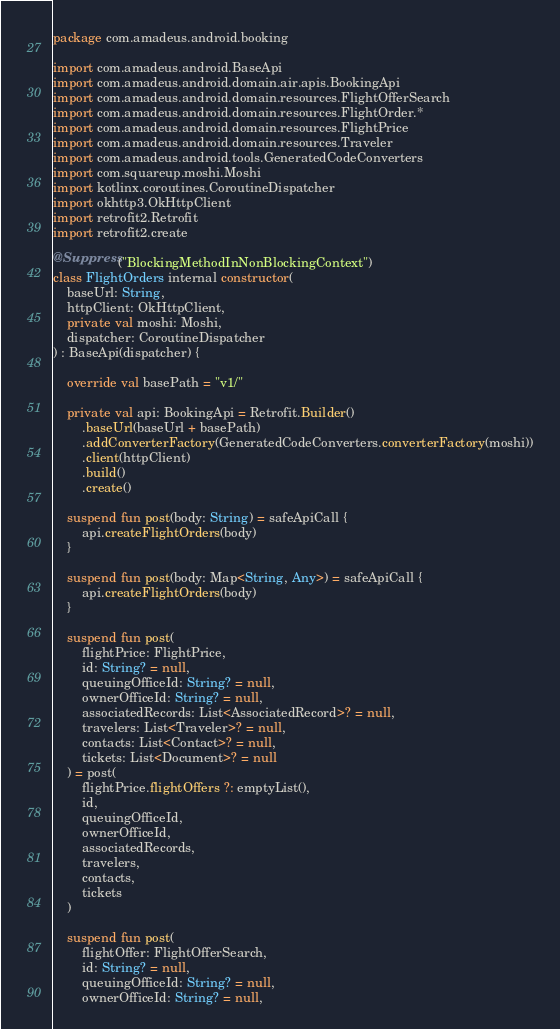<code> <loc_0><loc_0><loc_500><loc_500><_Kotlin_>package com.amadeus.android.booking

import com.amadeus.android.BaseApi
import com.amadeus.android.domain.air.apis.BookingApi
import com.amadeus.android.domain.resources.FlightOfferSearch
import com.amadeus.android.domain.resources.FlightOrder.*
import com.amadeus.android.domain.resources.FlightPrice
import com.amadeus.android.domain.resources.Traveler
import com.amadeus.android.tools.GeneratedCodeConverters
import com.squareup.moshi.Moshi
import kotlinx.coroutines.CoroutineDispatcher
import okhttp3.OkHttpClient
import retrofit2.Retrofit
import retrofit2.create

@Suppress("BlockingMethodInNonBlockingContext")
class FlightOrders internal constructor(
    baseUrl: String,
    httpClient: OkHttpClient,
    private val moshi: Moshi,
    dispatcher: CoroutineDispatcher
) : BaseApi(dispatcher) {

    override val basePath = "v1/"

    private val api: BookingApi = Retrofit.Builder()
        .baseUrl(baseUrl + basePath)
        .addConverterFactory(GeneratedCodeConverters.converterFactory(moshi))
        .client(httpClient)
        .build()
        .create()

    suspend fun post(body: String) = safeApiCall {
        api.createFlightOrders(body)
    }

    suspend fun post(body: Map<String, Any>) = safeApiCall {
        api.createFlightOrders(body)
    }

    suspend fun post(
        flightPrice: FlightPrice,
        id: String? = null,
        queuingOfficeId: String? = null,
        ownerOfficeId: String? = null,
        associatedRecords: List<AssociatedRecord>? = null,
        travelers: List<Traveler>? = null,
        contacts: List<Contact>? = null,
        tickets: List<Document>? = null
    ) = post(
        flightPrice.flightOffers ?: emptyList(),
        id,
        queuingOfficeId,
        ownerOfficeId,
        associatedRecords,
        travelers,
        contacts,
        tickets
    )

    suspend fun post(
        flightOffer: FlightOfferSearch,
        id: String? = null,
        queuingOfficeId: String? = null,
        ownerOfficeId: String? = null,</code> 